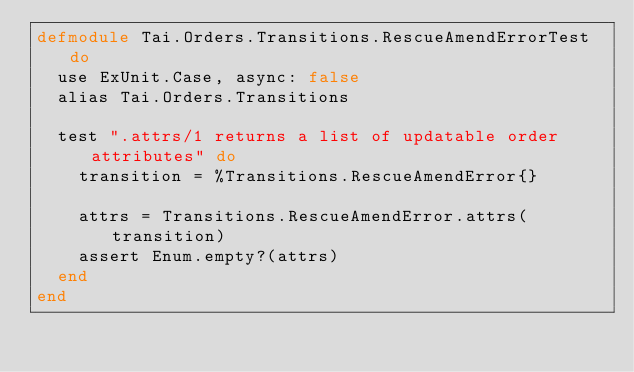<code> <loc_0><loc_0><loc_500><loc_500><_Elixir_>defmodule Tai.Orders.Transitions.RescueAmendErrorTest do
  use ExUnit.Case, async: false
  alias Tai.Orders.Transitions

  test ".attrs/1 returns a list of updatable order attributes" do
    transition = %Transitions.RescueAmendError{}

    attrs = Transitions.RescueAmendError.attrs(transition)
    assert Enum.empty?(attrs)
  end
end
</code> 